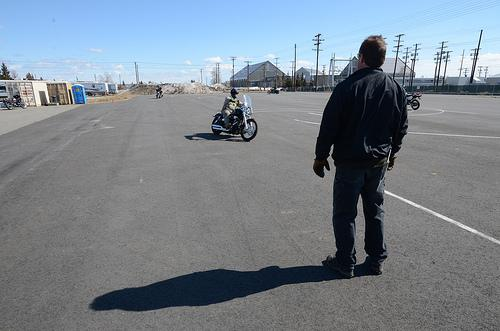Question: why is he standing?
Choices:
A. To watch parade.
B. To watch the motorcycles.
C. Because the anthem is playing.
D. Because his guests just walked in.
Answer with the letter. Answer: B Question: when was the picture taken?
Choices:
A. In the daytime.
B. At night.
C. After a big storm.
D. While it was snowing.
Answer with the letter. Answer: A Question: who is in the picture?
Choices:
A. A lady.
B. Two men.
C. A couple.
D. Nobody.
Answer with the letter. Answer: B Question: how many motorcycles are there?
Choices:
A. 3.
B. 4.
C. 5.
D. 2.
Answer with the letter. Answer: D 